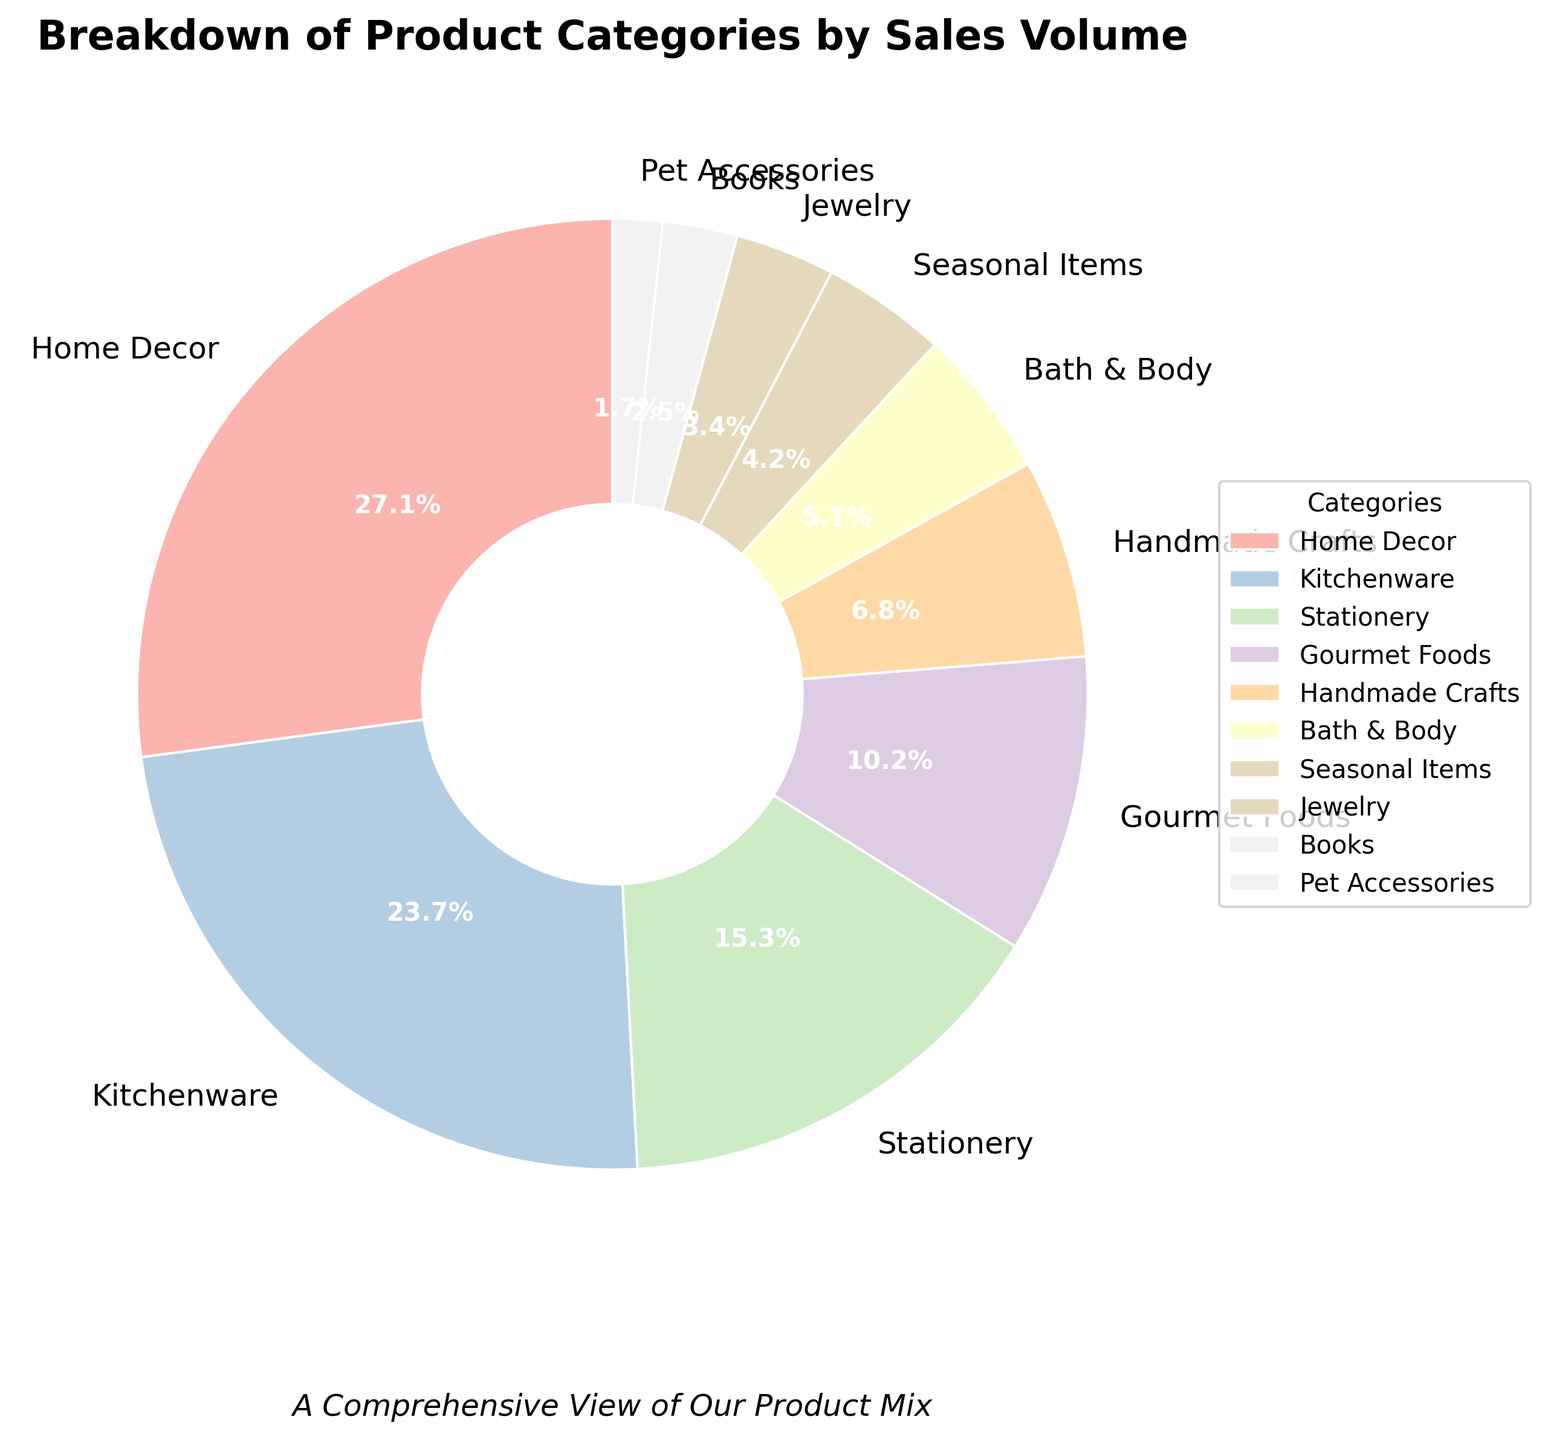Which category has the highest sales volume? By looking at the pie chart, we can see that the largest slice corresponds to the "Home Decor" category.
Answer: Home Decor Which category has the lowest sales volume? By examining the smallest slice on the pie chart, which belongs to the "Pet Accessories".
Answer: Pet Accessories What is the difference in sales volume between Home Decor and Kitchenware? Home Decor has a sales volume of 32, and Kitchenware has a sales volume of 28. The difference is 32 - 28.
Answer: 4 How many categories have a sales volume greater than 10? By looking at the pie chart, categories with more than 10 sales volume are Home Decor, Kitchenware, Stationery, and Gourmet Foods. There are 4 such categories.
Answer: 4 Which categories together make up approximately half of the total sales volume? Home Decor and Kitchenware combined have a sales volume of 32+28=60. The total sales volume is 118, so they make up approximately half of the total (60/118 ≈ 50.8%).
Answer: Home Decor and Kitchenware What is the combined sales volume of Books and Jewelry? Books have a sales volume of 3, and Jewelry has a sales volume of 4. Their combined sales volume is 3 + 4.
Answer: 7 Which category has a sales volume closest to the median value? Sorting the sales volumes, the median value is the 6th value: Home Decor (32), Kitchenware (28), Stationery (18), Gourmet Foods (12), Handmade Crafts (8), Bath & Body (6). So, the median sales volume is 8, which is the sales volume for Handmade Crafts.
Answer: Handmade Crafts Which category occupies the smallest area on the pie chart? The smallest slice on the pie chart corresponds to the "Pet Accessories" category.
Answer: Pet Accessories Comparing Bath & Body and Handmade Crafts, which has a higher sales volume and by how much? Bath & Body has a sales volume of 6, and Handmade Crafts has a sales volume of 8. Handmade Crafts has 8 - 6 = 2 more sales volume than Bath & Body.
Answer: Handmade Crafts, by 2 Which slice appears the second largest on the pie chart? The pie chart shows the "Kitchenware" slice as the second largest after "Home Decor".
Answer: Kitchenware 